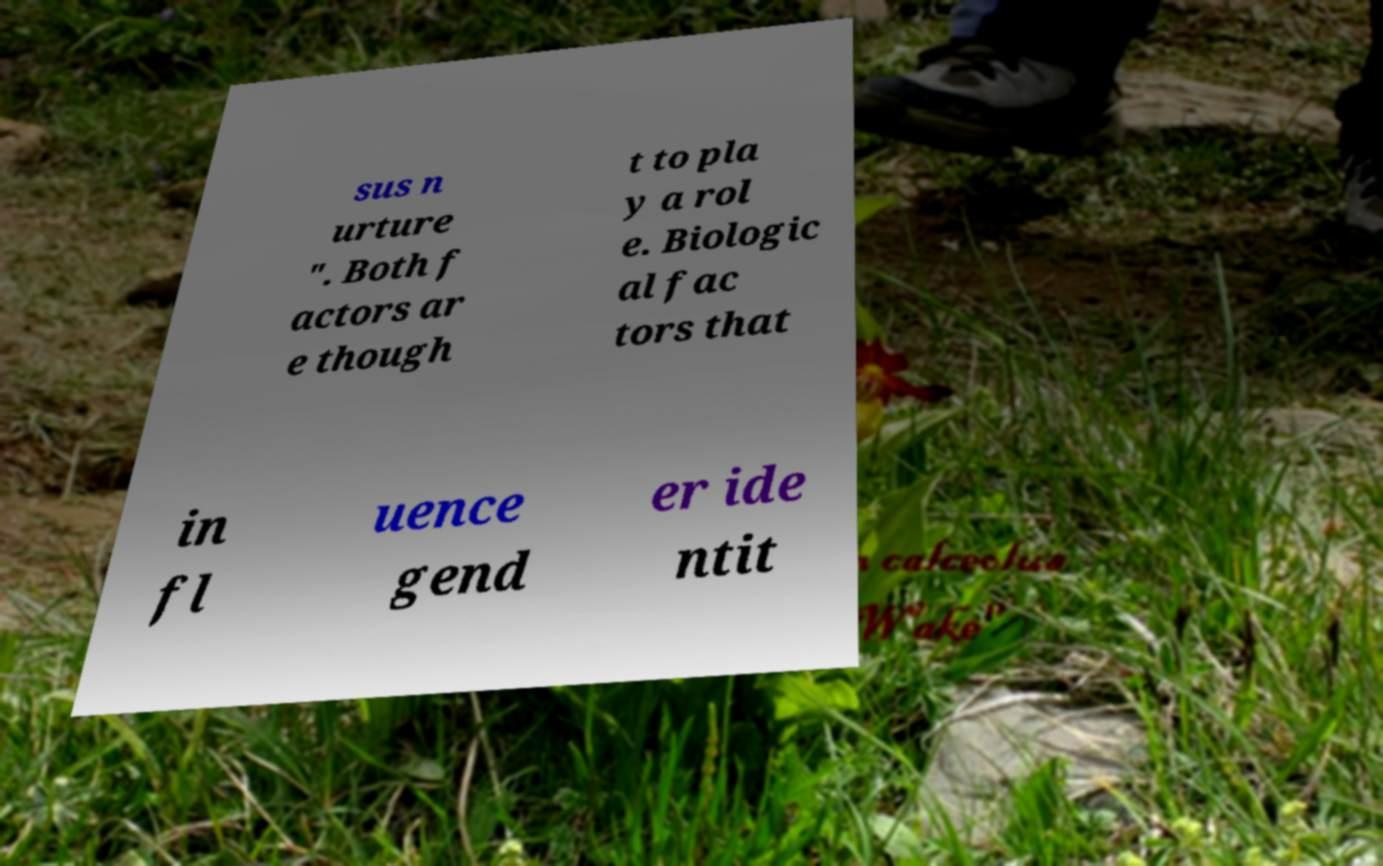Could you extract and type out the text from this image? sus n urture ". Both f actors ar e though t to pla y a rol e. Biologic al fac tors that in fl uence gend er ide ntit 